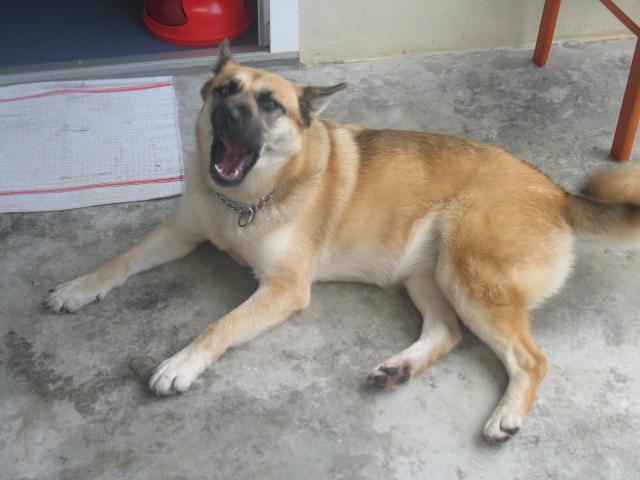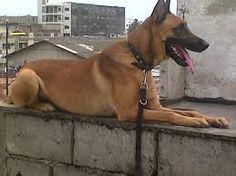The first image is the image on the left, the second image is the image on the right. Given the left and right images, does the statement "An image shows a dog and a cat together in a resting pose." hold true? Answer yes or no. No. The first image is the image on the left, the second image is the image on the right. Assess this claim about the two images: "A dog and a cat are lying down together.". Correct or not? Answer yes or no. No. 